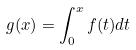<formula> <loc_0><loc_0><loc_500><loc_500>g ( x ) = \int _ { 0 } ^ { x } f ( t ) d t</formula> 